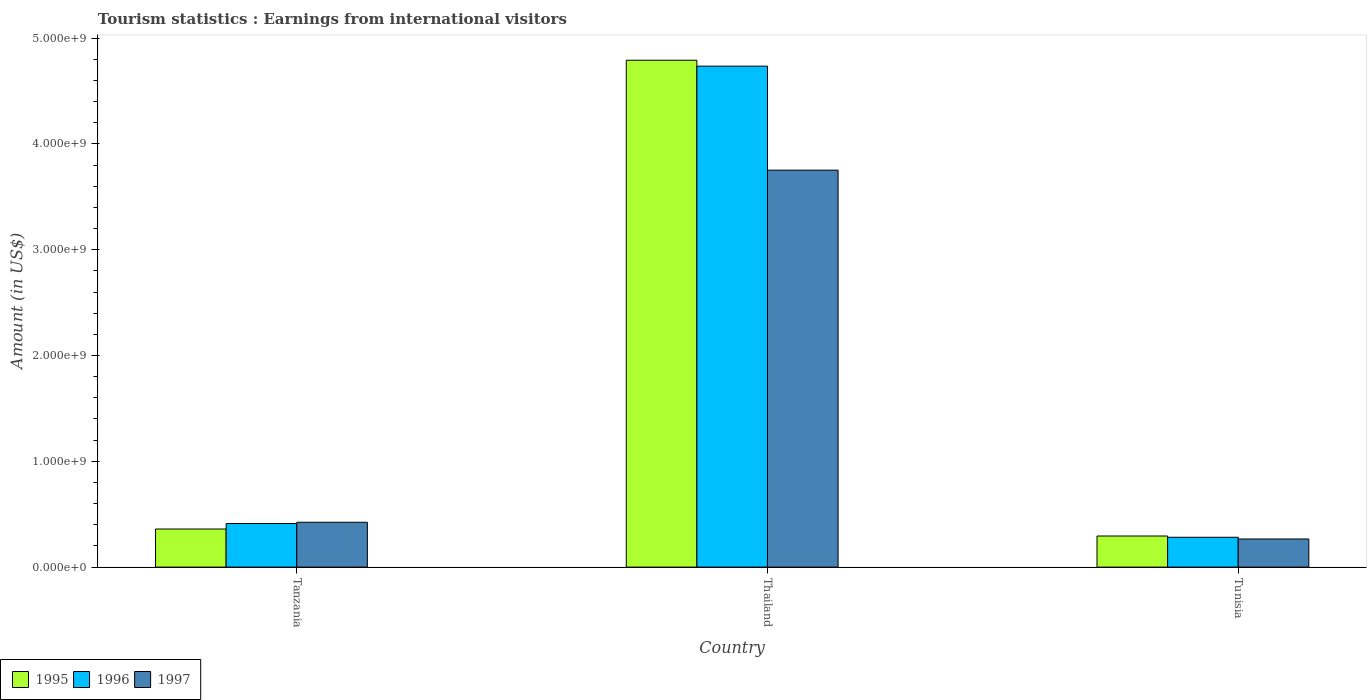Are the number of bars per tick equal to the number of legend labels?
Keep it short and to the point. Yes. How many bars are there on the 3rd tick from the left?
Keep it short and to the point. 3. What is the label of the 2nd group of bars from the left?
Make the answer very short. Thailand. What is the earnings from international visitors in 1995 in Tanzania?
Offer a terse response. 3.60e+08. Across all countries, what is the maximum earnings from international visitors in 1996?
Offer a very short reply. 4.74e+09. Across all countries, what is the minimum earnings from international visitors in 1996?
Keep it short and to the point. 2.82e+08. In which country was the earnings from international visitors in 1995 maximum?
Offer a very short reply. Thailand. In which country was the earnings from international visitors in 1997 minimum?
Your answer should be compact. Tunisia. What is the total earnings from international visitors in 1997 in the graph?
Give a very brief answer. 4.44e+09. What is the difference between the earnings from international visitors in 1995 in Tanzania and that in Thailand?
Offer a terse response. -4.43e+09. What is the difference between the earnings from international visitors in 1995 in Tunisia and the earnings from international visitors in 1996 in Tanzania?
Your answer should be very brief. -1.18e+08. What is the average earnings from international visitors in 1995 per country?
Offer a terse response. 1.82e+09. What is the difference between the earnings from international visitors of/in 1996 and earnings from international visitors of/in 1997 in Thailand?
Provide a short and direct response. 9.83e+08. What is the ratio of the earnings from international visitors in 1995 in Tanzania to that in Tunisia?
Give a very brief answer. 1.22. Is the earnings from international visitors in 1995 in Thailand less than that in Tunisia?
Make the answer very short. No. Is the difference between the earnings from international visitors in 1996 in Thailand and Tunisia greater than the difference between the earnings from international visitors in 1997 in Thailand and Tunisia?
Keep it short and to the point. Yes. What is the difference between the highest and the second highest earnings from international visitors in 1995?
Make the answer very short. 4.43e+09. What is the difference between the highest and the lowest earnings from international visitors in 1996?
Your answer should be very brief. 4.45e+09. In how many countries, is the earnings from international visitors in 1996 greater than the average earnings from international visitors in 1996 taken over all countries?
Give a very brief answer. 1. Is the sum of the earnings from international visitors in 1997 in Tanzania and Thailand greater than the maximum earnings from international visitors in 1996 across all countries?
Give a very brief answer. No. Is it the case that in every country, the sum of the earnings from international visitors in 1997 and earnings from international visitors in 1996 is greater than the earnings from international visitors in 1995?
Provide a short and direct response. Yes. Are all the bars in the graph horizontal?
Provide a short and direct response. No. How many countries are there in the graph?
Offer a terse response. 3. Does the graph contain any zero values?
Keep it short and to the point. No. Does the graph contain grids?
Ensure brevity in your answer.  No. How many legend labels are there?
Offer a very short reply. 3. What is the title of the graph?
Keep it short and to the point. Tourism statistics : Earnings from international visitors. Does "2009" appear as one of the legend labels in the graph?
Provide a succinct answer. No. What is the label or title of the X-axis?
Give a very brief answer. Country. What is the Amount (in US$) of 1995 in Tanzania?
Offer a very short reply. 3.60e+08. What is the Amount (in US$) in 1996 in Tanzania?
Keep it short and to the point. 4.12e+08. What is the Amount (in US$) of 1997 in Tanzania?
Offer a terse response. 4.24e+08. What is the Amount (in US$) of 1995 in Thailand?
Make the answer very short. 4.79e+09. What is the Amount (in US$) in 1996 in Thailand?
Your answer should be very brief. 4.74e+09. What is the Amount (in US$) in 1997 in Thailand?
Provide a short and direct response. 3.75e+09. What is the Amount (in US$) of 1995 in Tunisia?
Ensure brevity in your answer.  2.94e+08. What is the Amount (in US$) of 1996 in Tunisia?
Offer a terse response. 2.82e+08. What is the Amount (in US$) in 1997 in Tunisia?
Provide a succinct answer. 2.66e+08. Across all countries, what is the maximum Amount (in US$) of 1995?
Give a very brief answer. 4.79e+09. Across all countries, what is the maximum Amount (in US$) of 1996?
Ensure brevity in your answer.  4.74e+09. Across all countries, what is the maximum Amount (in US$) of 1997?
Give a very brief answer. 3.75e+09. Across all countries, what is the minimum Amount (in US$) in 1995?
Give a very brief answer. 2.94e+08. Across all countries, what is the minimum Amount (in US$) of 1996?
Provide a short and direct response. 2.82e+08. Across all countries, what is the minimum Amount (in US$) of 1997?
Keep it short and to the point. 2.66e+08. What is the total Amount (in US$) of 1995 in the graph?
Offer a terse response. 5.44e+09. What is the total Amount (in US$) of 1996 in the graph?
Offer a terse response. 5.43e+09. What is the total Amount (in US$) of 1997 in the graph?
Offer a very short reply. 4.44e+09. What is the difference between the Amount (in US$) in 1995 in Tanzania and that in Thailand?
Your response must be concise. -4.43e+09. What is the difference between the Amount (in US$) of 1996 in Tanzania and that in Thailand?
Provide a short and direct response. -4.32e+09. What is the difference between the Amount (in US$) in 1997 in Tanzania and that in Thailand?
Your answer should be compact. -3.33e+09. What is the difference between the Amount (in US$) in 1995 in Tanzania and that in Tunisia?
Your response must be concise. 6.60e+07. What is the difference between the Amount (in US$) of 1996 in Tanzania and that in Tunisia?
Offer a very short reply. 1.30e+08. What is the difference between the Amount (in US$) in 1997 in Tanzania and that in Tunisia?
Provide a short and direct response. 1.58e+08. What is the difference between the Amount (in US$) of 1995 in Thailand and that in Tunisia?
Give a very brief answer. 4.50e+09. What is the difference between the Amount (in US$) in 1996 in Thailand and that in Tunisia?
Provide a short and direct response. 4.45e+09. What is the difference between the Amount (in US$) in 1997 in Thailand and that in Tunisia?
Give a very brief answer. 3.49e+09. What is the difference between the Amount (in US$) in 1995 in Tanzania and the Amount (in US$) in 1996 in Thailand?
Your answer should be very brief. -4.38e+09. What is the difference between the Amount (in US$) of 1995 in Tanzania and the Amount (in US$) of 1997 in Thailand?
Keep it short and to the point. -3.39e+09. What is the difference between the Amount (in US$) in 1996 in Tanzania and the Amount (in US$) in 1997 in Thailand?
Offer a terse response. -3.34e+09. What is the difference between the Amount (in US$) in 1995 in Tanzania and the Amount (in US$) in 1996 in Tunisia?
Provide a short and direct response. 7.80e+07. What is the difference between the Amount (in US$) in 1995 in Tanzania and the Amount (in US$) in 1997 in Tunisia?
Offer a terse response. 9.40e+07. What is the difference between the Amount (in US$) in 1996 in Tanzania and the Amount (in US$) in 1997 in Tunisia?
Make the answer very short. 1.46e+08. What is the difference between the Amount (in US$) in 1995 in Thailand and the Amount (in US$) in 1996 in Tunisia?
Provide a succinct answer. 4.51e+09. What is the difference between the Amount (in US$) in 1995 in Thailand and the Amount (in US$) in 1997 in Tunisia?
Your answer should be compact. 4.52e+09. What is the difference between the Amount (in US$) in 1996 in Thailand and the Amount (in US$) in 1997 in Tunisia?
Your answer should be compact. 4.47e+09. What is the average Amount (in US$) in 1995 per country?
Your response must be concise. 1.82e+09. What is the average Amount (in US$) in 1996 per country?
Offer a very short reply. 1.81e+09. What is the average Amount (in US$) in 1997 per country?
Keep it short and to the point. 1.48e+09. What is the difference between the Amount (in US$) in 1995 and Amount (in US$) in 1996 in Tanzania?
Offer a very short reply. -5.20e+07. What is the difference between the Amount (in US$) of 1995 and Amount (in US$) of 1997 in Tanzania?
Ensure brevity in your answer.  -6.40e+07. What is the difference between the Amount (in US$) in 1996 and Amount (in US$) in 1997 in Tanzania?
Your answer should be very brief. -1.20e+07. What is the difference between the Amount (in US$) in 1995 and Amount (in US$) in 1996 in Thailand?
Give a very brief answer. 5.60e+07. What is the difference between the Amount (in US$) in 1995 and Amount (in US$) in 1997 in Thailand?
Make the answer very short. 1.04e+09. What is the difference between the Amount (in US$) of 1996 and Amount (in US$) of 1997 in Thailand?
Make the answer very short. 9.83e+08. What is the difference between the Amount (in US$) in 1995 and Amount (in US$) in 1997 in Tunisia?
Your answer should be very brief. 2.80e+07. What is the difference between the Amount (in US$) in 1996 and Amount (in US$) in 1997 in Tunisia?
Ensure brevity in your answer.  1.60e+07. What is the ratio of the Amount (in US$) in 1995 in Tanzania to that in Thailand?
Your response must be concise. 0.08. What is the ratio of the Amount (in US$) of 1996 in Tanzania to that in Thailand?
Offer a very short reply. 0.09. What is the ratio of the Amount (in US$) of 1997 in Tanzania to that in Thailand?
Offer a very short reply. 0.11. What is the ratio of the Amount (in US$) of 1995 in Tanzania to that in Tunisia?
Give a very brief answer. 1.22. What is the ratio of the Amount (in US$) of 1996 in Tanzania to that in Tunisia?
Give a very brief answer. 1.46. What is the ratio of the Amount (in US$) in 1997 in Tanzania to that in Tunisia?
Make the answer very short. 1.59. What is the ratio of the Amount (in US$) of 1995 in Thailand to that in Tunisia?
Offer a terse response. 16.3. What is the ratio of the Amount (in US$) in 1996 in Thailand to that in Tunisia?
Ensure brevity in your answer.  16.79. What is the ratio of the Amount (in US$) in 1997 in Thailand to that in Tunisia?
Offer a very short reply. 14.11. What is the difference between the highest and the second highest Amount (in US$) in 1995?
Your answer should be very brief. 4.43e+09. What is the difference between the highest and the second highest Amount (in US$) in 1996?
Keep it short and to the point. 4.32e+09. What is the difference between the highest and the second highest Amount (in US$) in 1997?
Keep it short and to the point. 3.33e+09. What is the difference between the highest and the lowest Amount (in US$) in 1995?
Ensure brevity in your answer.  4.50e+09. What is the difference between the highest and the lowest Amount (in US$) in 1996?
Your response must be concise. 4.45e+09. What is the difference between the highest and the lowest Amount (in US$) of 1997?
Your response must be concise. 3.49e+09. 